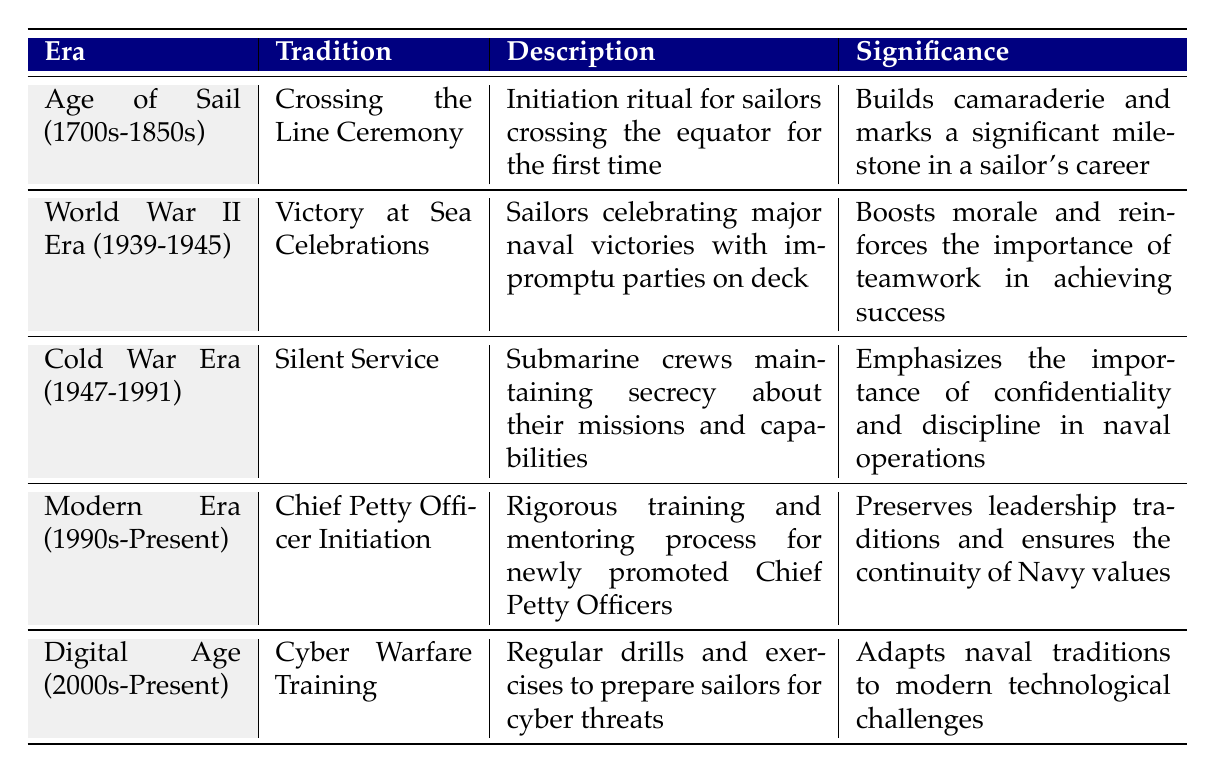What tradition is associated with the World War II Era? Referring to the table, the tradition listed under the World War II Era (1939-1945) is "Victory at Sea Celebrations."
Answer: Victory at Sea Celebrations What is the significance of the Crossing the Line Ceremony? The table states that the significance of the Crossing the Line Ceremony is that it builds camaraderie and marks a significant milestone in a sailor's career.
Answer: Builds camaraderie and marks milestone Is Cyber Warfare Training a tradition from the Cold War Era? The table shows that Cyber Warfare Training is listed under the Digital Age (2000s-Present), so it is not from the Cold War Era.
Answer: No What description corresponds to the Chief Petty Officer Initiation? According to the table, the description for the Chief Petty Officer Initiation is a rigorous training and mentoring process for newly promoted Chief Petty Officers.
Answer: Rigorous training and mentoring process Which era emphasizes confidentiality and discipline in naval operations? The table indicates that the Cold War Era (1947-1991) emphasizes confidentiality and discipline in naval operations through the tradition of Silent Service.
Answer: Cold War Era What is the average significance of traditions from the Age of Sail and World War II Era? The table lists the significance of the Age of Sail's tradition as building camaraderie, and the World War II's as boosting morale. Combining these values doesn't lead to an average since they are qualitative, but they both emphasize unity and teamwork.
Answer: Qualitative values, not a numerical average Does the table include any traditions from the 1990s? Yes, the table includes the Chief Petty Officer Initiation, which is from the Modern Era (1990s-Present).
Answer: Yes Which tradition marks a significant milestone for sailors? The tradition that marks a significant milestone for sailors is the Crossing the Line Ceremony as described in the table.
Answer: Crossing the Line Ceremony How many traditions are listed in the table for the Digital Age? The table indicates there is one tradition listed for the Digital Age (2000s-Present), which is Cyber Warfare Training.
Answer: One tradition 